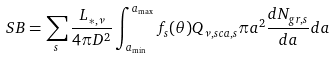<formula> <loc_0><loc_0><loc_500><loc_500>S B = \sum _ { s } \frac { L _ { * , \nu } } { 4 \pi D ^ { 2 } } \int _ { a _ { \min } } ^ { a _ { \max } } f _ { s } ( \theta ) Q _ { \nu , s c a , s } \pi a ^ { 2 } \frac { d N _ { g r , s } } { d a } d a</formula> 